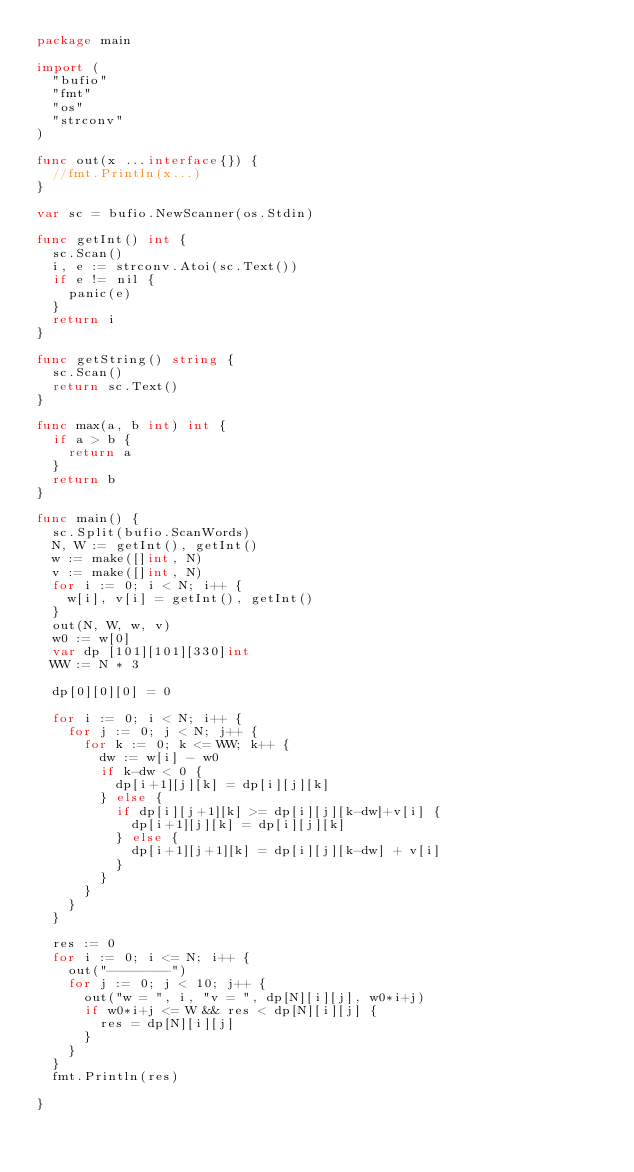Convert code to text. <code><loc_0><loc_0><loc_500><loc_500><_Go_>package main

import (
	"bufio"
	"fmt"
	"os"
	"strconv"
)

func out(x ...interface{}) {
	//fmt.Println(x...)
}

var sc = bufio.NewScanner(os.Stdin)

func getInt() int {
	sc.Scan()
	i, e := strconv.Atoi(sc.Text())
	if e != nil {
		panic(e)
	}
	return i
}

func getString() string {
	sc.Scan()
	return sc.Text()
}

func max(a, b int) int {
	if a > b {
		return a
	}
	return b
}

func main() {
	sc.Split(bufio.ScanWords)
	N, W := getInt(), getInt()
	w := make([]int, N)
	v := make([]int, N)
	for i := 0; i < N; i++ {
		w[i], v[i] = getInt(), getInt()
	}
	out(N, W, w, v)
	w0 := w[0]
	var dp [101][101][330]int
	WW := N * 3

	dp[0][0][0] = 0

	for i := 0; i < N; i++ {
		for j := 0; j < N; j++ {
			for k := 0; k <= WW; k++ {
				dw := w[i] - w0
				if k-dw < 0 {
					dp[i+1][j][k] = dp[i][j][k]
				} else {
					if dp[i][j+1][k] >= dp[i][j][k-dw]+v[i] {
						dp[i+1][j][k] = dp[i][j][k]
					} else {
						dp[i+1][j+1][k] = dp[i][j][k-dw] + v[i]
					}
				}
			}
		}
	}

	res := 0
	for i := 0; i <= N; i++ {
		out("--------")
		for j := 0; j < 10; j++ {
			out("w = ", i, "v = ", dp[N][i][j], w0*i+j)
			if w0*i+j <= W && res < dp[N][i][j] {
				res = dp[N][i][j]
			}
		}
	}
	fmt.Println(res)

}
</code> 